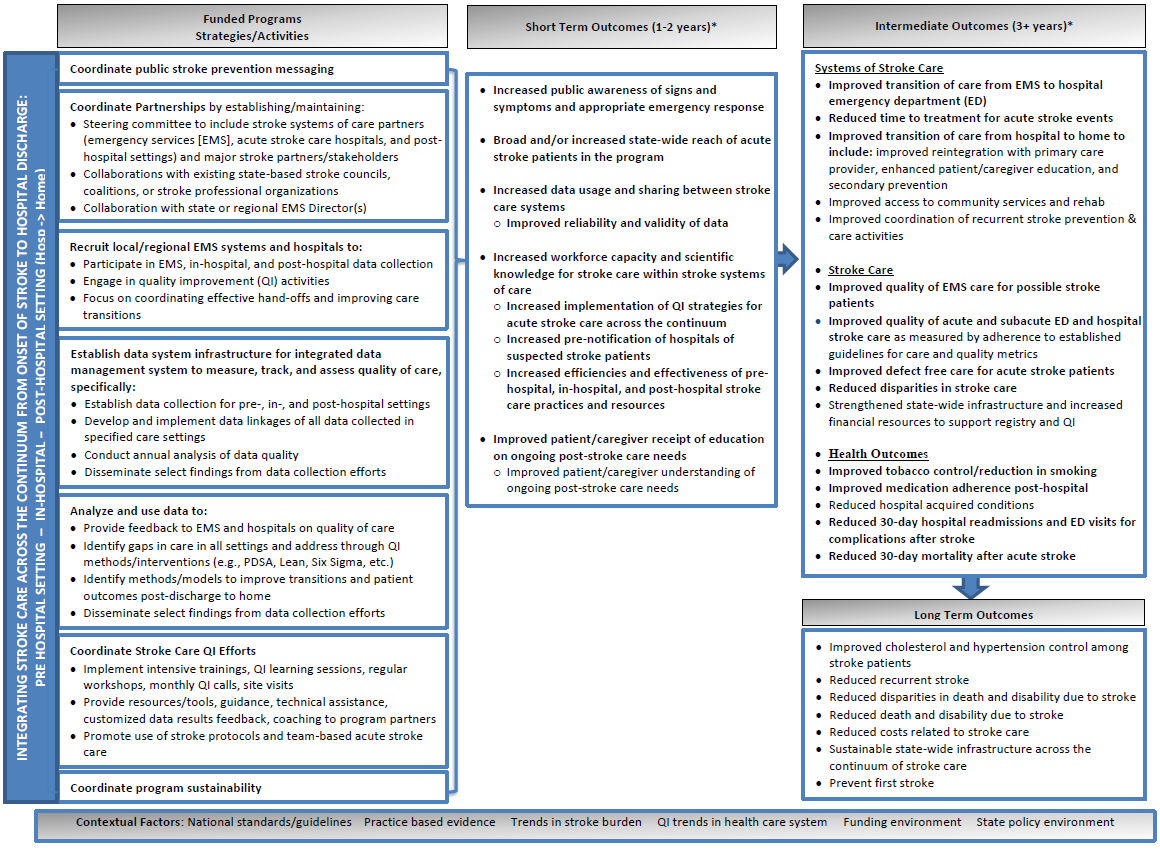Considering the structure and content of this strategic plan, what might be the potential challenges in coordinating public stroke prevention messaging across multiple stakeholders as outlined in the "Funded Programs Strategies/Activities" section? Based on the image, potential challenges in coordinating public stroke prevention messaging could include ensuring consistent messaging across diverse committees and stakeholders, integrating stroke care systems in emergency, hospital, and post-hospital settings, and collaborating with existing state-based stroke councils, organizations, and major stakeholders. Additional challenges could involve maintaining engagement and collaboration across varied professional organizations and aligning the messaging with national standards and guidelines, as indicated in the "Contextual Factors" section. 